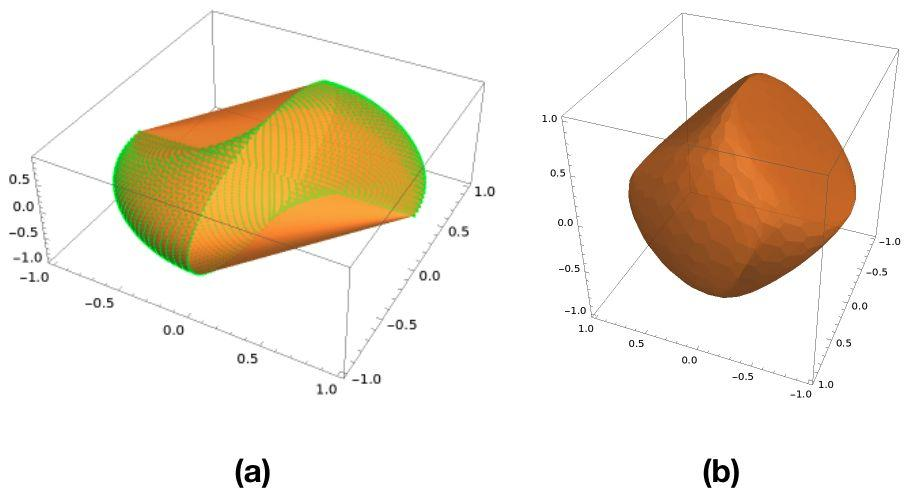How would the different surfaces in Figures (a) and (b) affect their practical applications? The surface in Figure (a) with its sinusoidal pattern might be useful in fields where dynamic properties are critical, such as aerodynamics or acoustics, where the modulation can impact wave propagation or airflow. Conversely, the smooth surface of Figure (b) could be more suited for applications requiring stability and consistency, such as manufacturing components where uniformity is critical to ensure fit and function. 